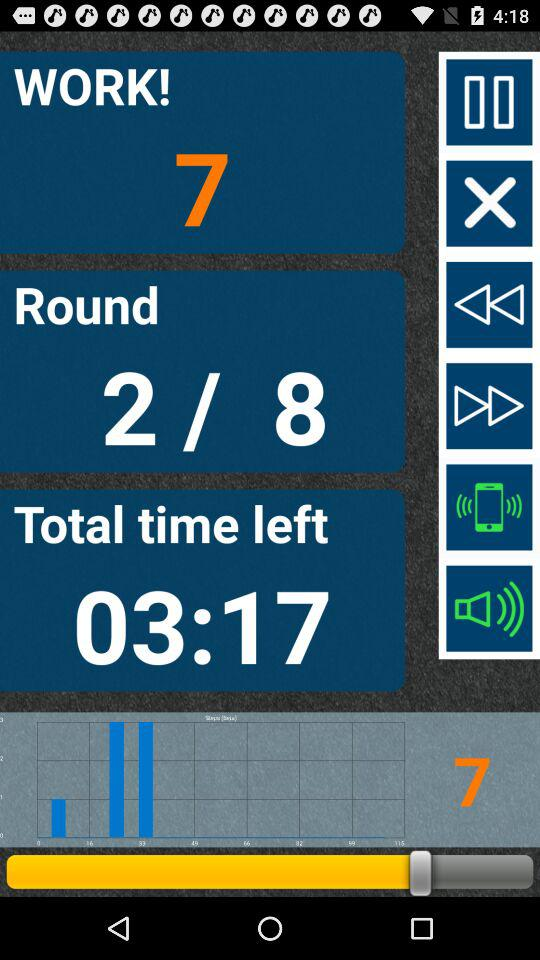What is the total time left? The total time left is 03:17. 